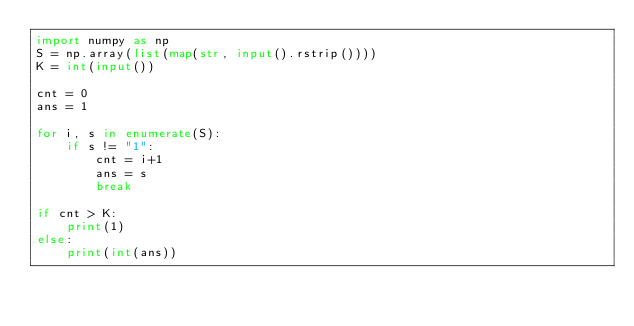<code> <loc_0><loc_0><loc_500><loc_500><_Python_>import numpy as np
S = np.array(list(map(str, input().rstrip())))
K = int(input())

cnt = 0
ans = 1

for i, s in enumerate(S):
    if s != "1":
        cnt = i+1
        ans = s
        break

if cnt > K:
    print(1)
else:
    print(int(ans))</code> 